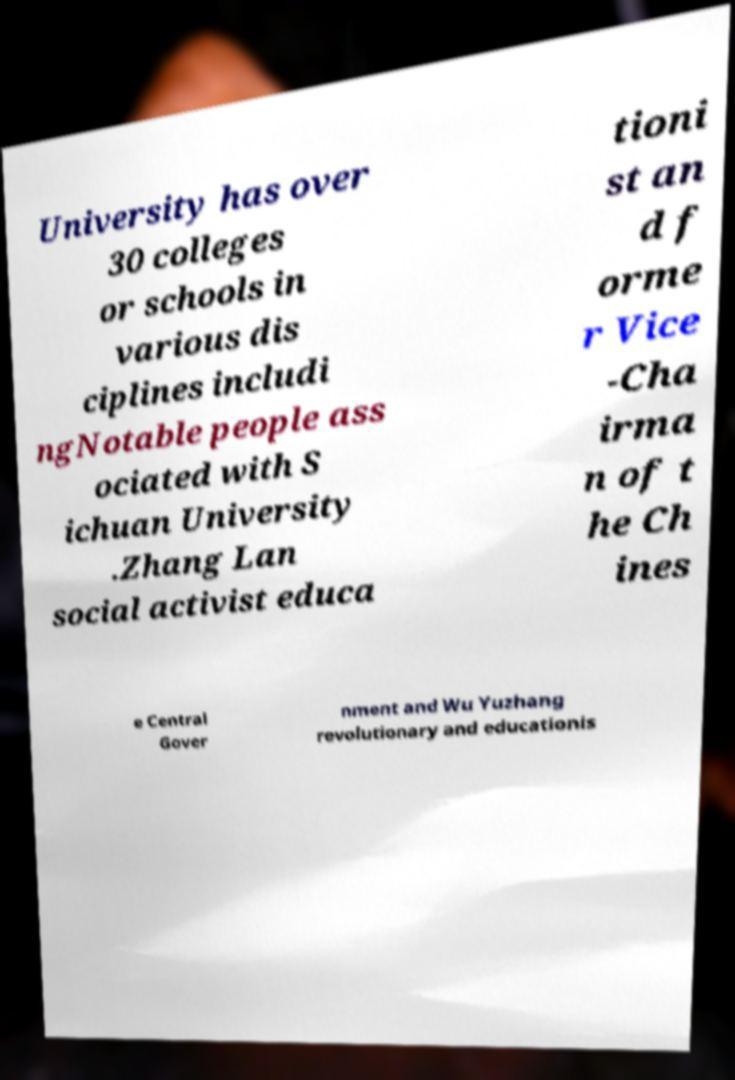There's text embedded in this image that I need extracted. Can you transcribe it verbatim? University has over 30 colleges or schools in various dis ciplines includi ngNotable people ass ociated with S ichuan University .Zhang Lan social activist educa tioni st an d f orme r Vice -Cha irma n of t he Ch ines e Central Gover nment and Wu Yuzhang revolutionary and educationis 